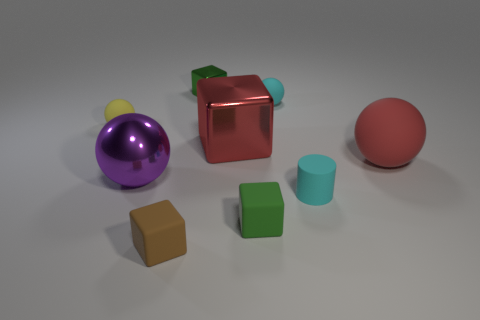The object that is both in front of the large red sphere and behind the small cyan cylinder is made of what material?
Your answer should be compact. Metal. There is a large ball that is on the left side of the small cyan rubber sphere; what color is it?
Keep it short and to the point. Purple. Is the number of large shiny blocks that are to the right of the small green rubber thing greater than the number of green objects?
Offer a terse response. No. What number of other objects are there of the same size as the green rubber object?
Keep it short and to the point. 5. There is a brown thing; what number of small cyan spheres are in front of it?
Your answer should be very brief. 0. Are there the same number of large metallic spheres behind the small yellow rubber object and yellow rubber things that are in front of the purple metal object?
Offer a terse response. Yes. What size is the cyan thing that is the same shape as the tiny yellow matte object?
Make the answer very short. Small. There is a green object behind the cylinder; what is its shape?
Provide a succinct answer. Cube. Are the red object that is on the left side of the large rubber ball and the tiny sphere that is behind the yellow sphere made of the same material?
Give a very brief answer. No. The purple shiny object is what shape?
Provide a short and direct response. Sphere. 